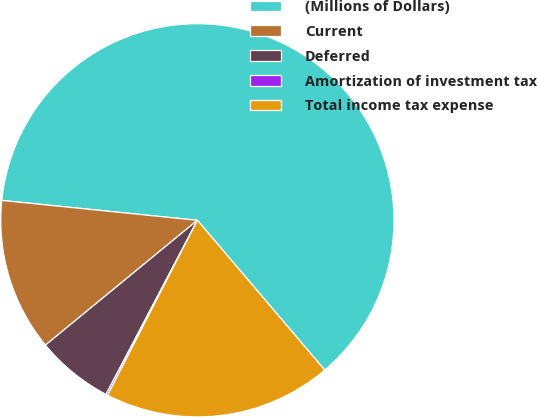Convert chart. <chart><loc_0><loc_0><loc_500><loc_500><pie_chart><fcel>(Millions of Dollars)<fcel>Current<fcel>Deferred<fcel>Amortization of investment tax<fcel>Total income tax expense<nl><fcel>62.17%<fcel>12.56%<fcel>6.36%<fcel>0.15%<fcel>18.76%<nl></chart> 